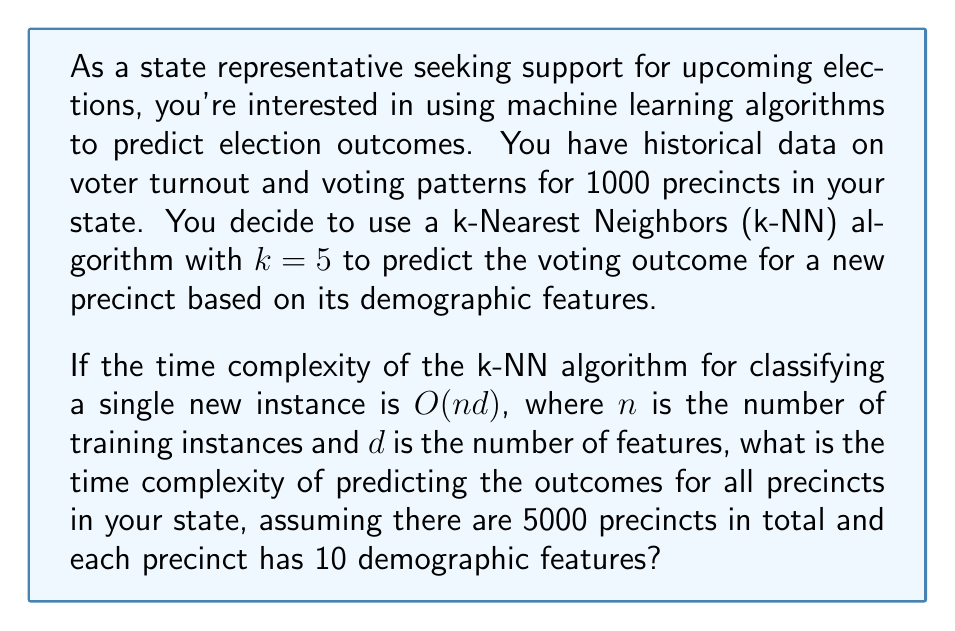Can you answer this question? Let's break this down step-by-step:

1) The k-NN algorithm has a time complexity of $O(nd)$ for classifying a single new instance, where:
   - $n$ is the number of training instances (1000 precincts in this case)
   - $d$ is the number of features (10 demographic features)

2) We need to predict outcomes for all precincts in the state, except those already in the training set:
   - Total precincts: 5000
   - Precincts in training set: 1000
   - Precincts to predict: 5000 - 1000 = 4000

3) For each of these 4000 precincts, we need to run the k-NN algorithm once.

4) Therefore, the total time complexity will be:
   $$O(4000 \cdot nd) = O(4000 \cdot 1000 \cdot 10)$$

5) Simplifying:
   $$O(40,000,000) = O(4 \cdot 10^7)$$

6) In Big O notation, we drop constant factors, so the final time complexity is:
   $$O(10^7)$$

This represents the order of magnitude of the number of operations required to predict the outcomes for all precincts in the state using the k-NN algorithm with the given parameters.
Answer: $O(10^7)$ 